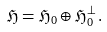Convert formula to latex. <formula><loc_0><loc_0><loc_500><loc_500>\mathfrak { H } = \mathfrak { H } _ { 0 } \oplus \mathfrak { H } _ { 0 } ^ { \bot } \, .</formula> 